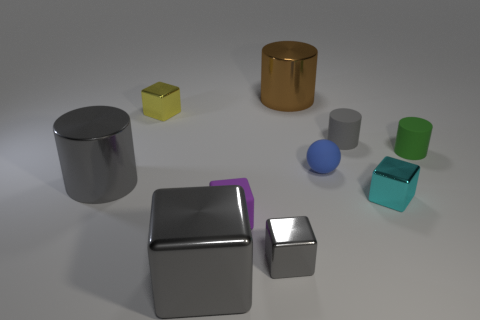Subtract all large cubes. How many cubes are left? 4 Subtract all red cylinders. How many gray cubes are left? 2 Subtract 2 cylinders. How many cylinders are left? 2 Subtract all purple blocks. How many blocks are left? 4 Subtract all cylinders. How many objects are left? 6 Subtract all green spheres. Subtract all cyan blocks. How many spheres are left? 1 Subtract all tiny gray matte cylinders. Subtract all tiny blocks. How many objects are left? 5 Add 1 big metal cubes. How many big metal cubes are left? 2 Add 7 small cyan metal balls. How many small cyan metal balls exist? 7 Subtract 0 purple cylinders. How many objects are left? 10 